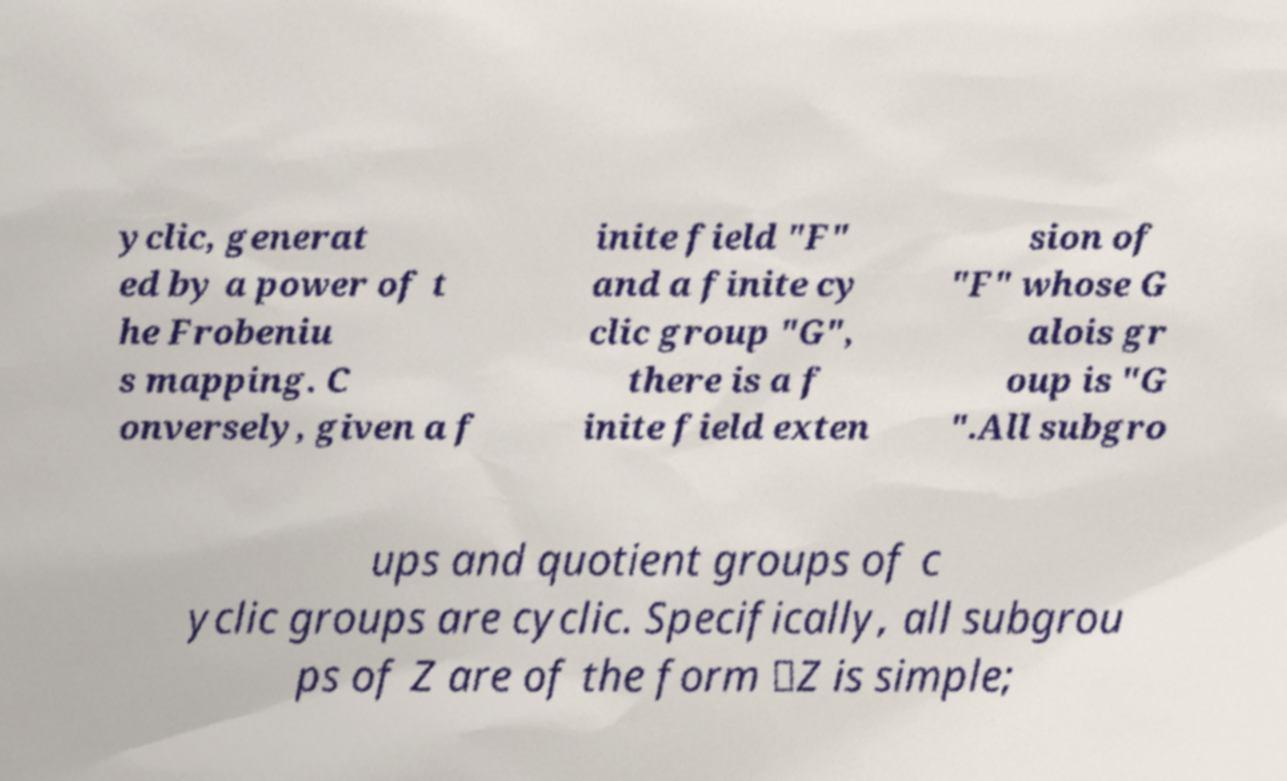What messages or text are displayed in this image? I need them in a readable, typed format. yclic, generat ed by a power of t he Frobeniu s mapping. C onversely, given a f inite field "F" and a finite cy clic group "G", there is a f inite field exten sion of "F" whose G alois gr oup is "G ".All subgro ups and quotient groups of c yclic groups are cyclic. Specifically, all subgrou ps of Z are of the form ⟨Z is simple; 